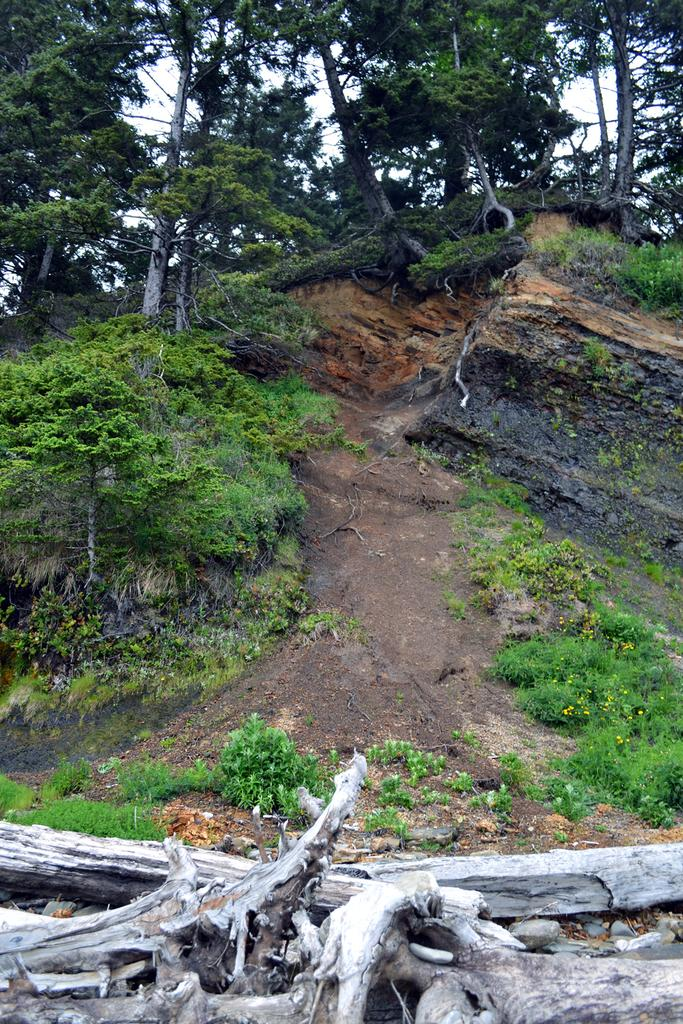What type of vegetation is present in the image? There are many trees and plants in the image. What feature do the plants have? The plants have flowers. What can be seen in the sky in the image? The sky is visible in the image. What material is the wooden object made of? The wooden object at the bottom of the image is made of wood. What type of behavior does the stove exhibit in the image? There is no stove present in the image. How many wings can be seen on the plants in the image? Plants do not have wings, so this question cannot be answered based on the provided facts. 